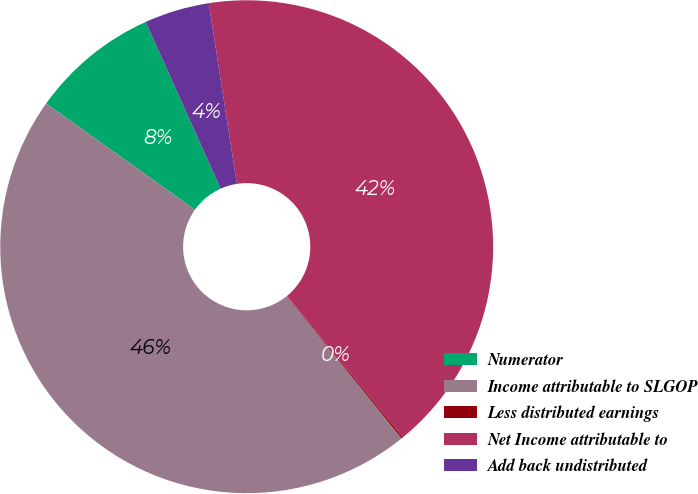<chart> <loc_0><loc_0><loc_500><loc_500><pie_chart><fcel>Numerator<fcel>Income attributable to SLGOP<fcel>Less distributed earnings<fcel>Net Income attributable to<fcel>Add back undistributed<nl><fcel>8.41%<fcel>45.69%<fcel>0.11%<fcel>41.53%<fcel>4.26%<nl></chart> 